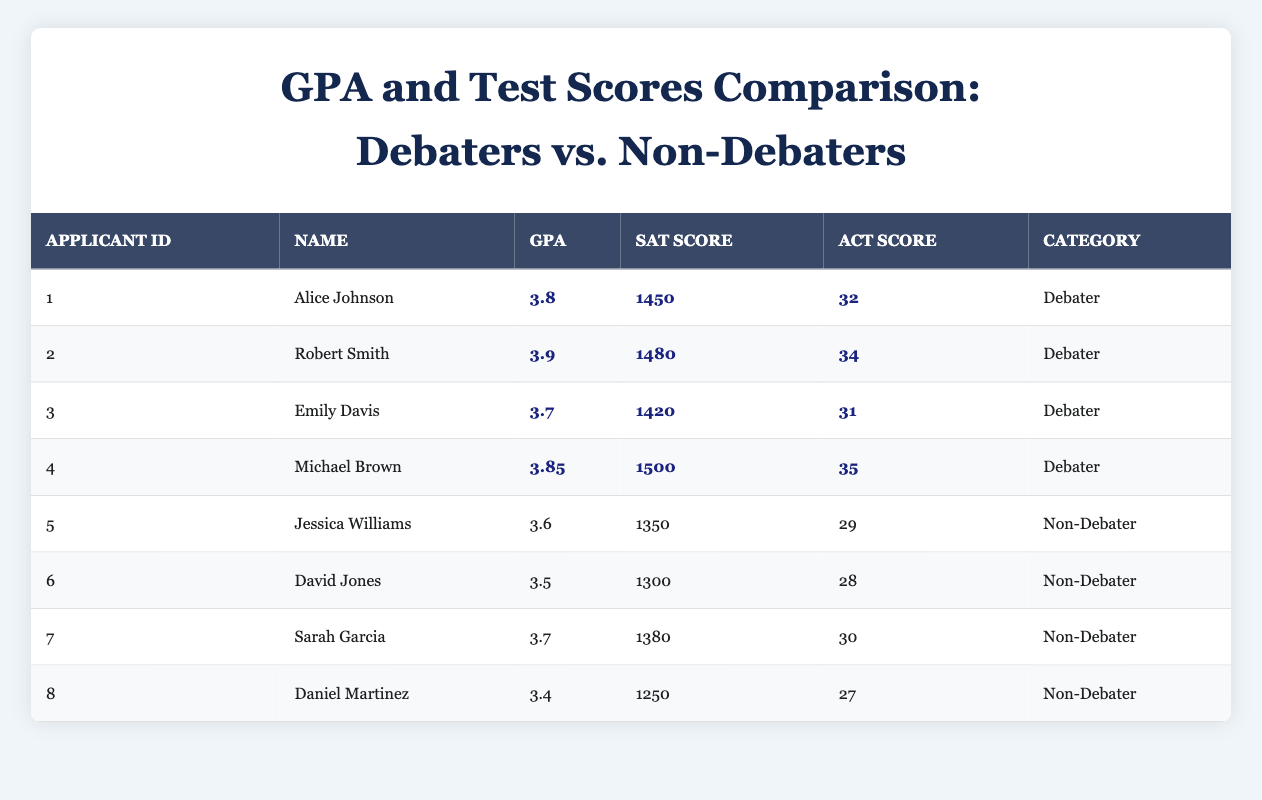What is the GPA of Robert Smith? The table shows that Robert Smith is listed as a debater with a GPA entry of 3.9 under the "GPA" column.
Answer: 3.9 What is the SAT score of Jessica Williams? The table indicates that Jessica Williams is a non-debater with an SAT score of 1350 under the "SAT Score" column.
Answer: 1350 What is the average ACT score of the debaters? There are 4 debaters with ACT scores of 32, 34, 31, and 35. The total is 32 + 34 + 31 + 35 = 132; then divided by the 4 debaters gives an average of 132/4 = 33.
Answer: 33 Which group has a higher median GPA, debaters or non-debaters? The GPA values for debaters are 3.8, 3.9, 3.7, and 3.85. When sorted, they are 3.7, 3.8, 3.85, 3.9; hence the median GPA is (3.8 + 3.85)/2 = 3.825. The GPA for non-debaters is 3.6, 3.5, 3.7, and 3.4, sorted as 3.4, 3.5, 3.6, 3.7, yielding a median of (3.5 + 3.6)/2 = 3.55. Thus, the debaters have a higher median GPA.
Answer: Debaters have a higher median GPA Is there any applicant with an ACT score below 30? Looking at the table, Sarah Garcia has an ACT score of 30, while Daniel Martinez has an ACT score of 27, which is below 30. Therefore, there is at least one applicant with an ACT score below 30.
Answer: Yes What is the combined SAT score of all applicants? The SAT scores are 1450, 1480, 1420, 1500 for debaters and 1350, 1300, 1380, 1250 for non-debaters. The total is (1450 + 1480 + 1420 + 1500 + 1350 + 1300 + 1380 + 1250) = 11130, thus the combined SAT score of all applicants is 11130.
Answer: 11130 